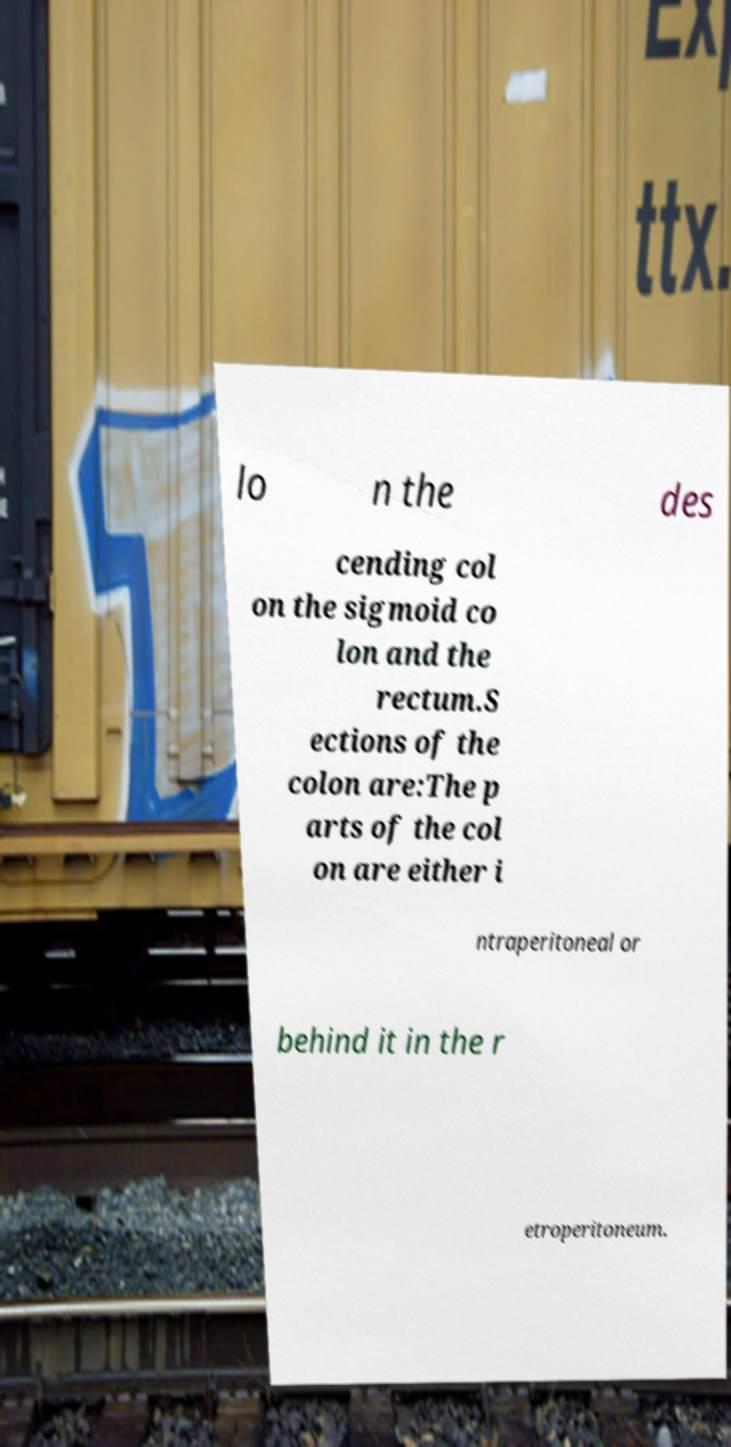Can you accurately transcribe the text from the provided image for me? lo n the des cending col on the sigmoid co lon and the rectum.S ections of the colon are:The p arts of the col on are either i ntraperitoneal or behind it in the r etroperitoneum. 